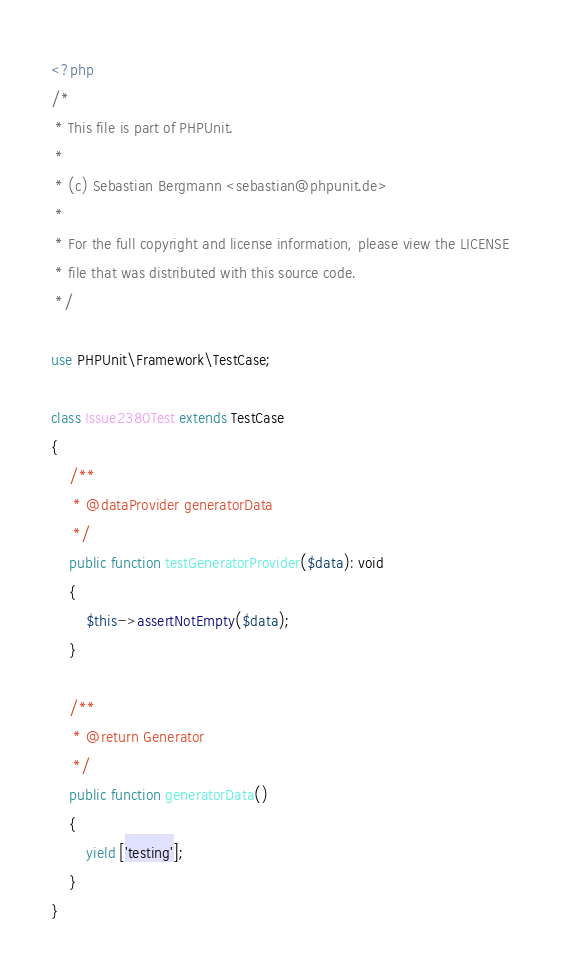Convert code to text. <code><loc_0><loc_0><loc_500><loc_500><_PHP_><?php
/*
 * This file is part of PHPUnit.
 *
 * (c) Sebastian Bergmann <sebastian@phpunit.de>
 *
 * For the full copyright and license information, please view the LICENSE
 * file that was distributed with this source code.
 */

use PHPUnit\Framework\TestCase;

class Issue2380Test extends TestCase
{
    /**
     * @dataProvider generatorData
     */
    public function testGeneratorProvider($data): void
    {
        $this->assertNotEmpty($data);
    }

    /**
     * @return Generator
     */
    public function generatorData()
    {
        yield ['testing'];
    }
}
</code> 